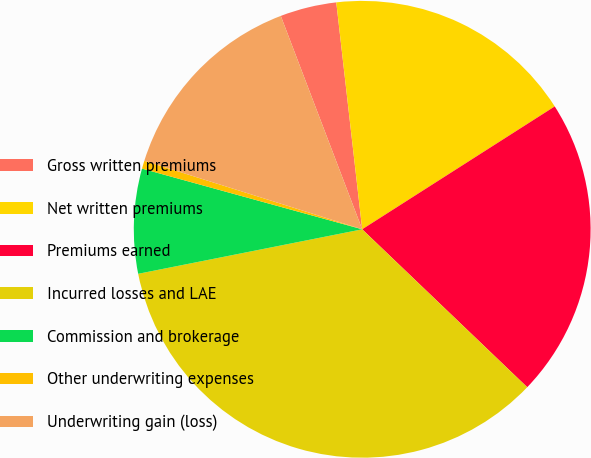<chart> <loc_0><loc_0><loc_500><loc_500><pie_chart><fcel>Gross written premiums<fcel>Net written premiums<fcel>Premiums earned<fcel>Incurred losses and LAE<fcel>Commission and brokerage<fcel>Other underwriting expenses<fcel>Underwriting gain (loss)<nl><fcel>3.99%<fcel>17.77%<fcel>21.19%<fcel>34.73%<fcel>7.4%<fcel>0.57%<fcel>14.35%<nl></chart> 